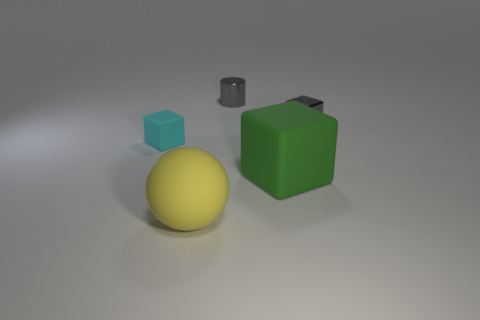What time of day does the lighting in the image suggest? The even and diffused lighting in the image suggests an interior setting with artificial lighting rather than a specific time of day. Could the lighting indicate anything about the intended use of the space? Given the neutral and soft nature of the lighting without harsh shadows, it may suggest a space designed for focus or inspection, such as a studio or a scientific setting. 